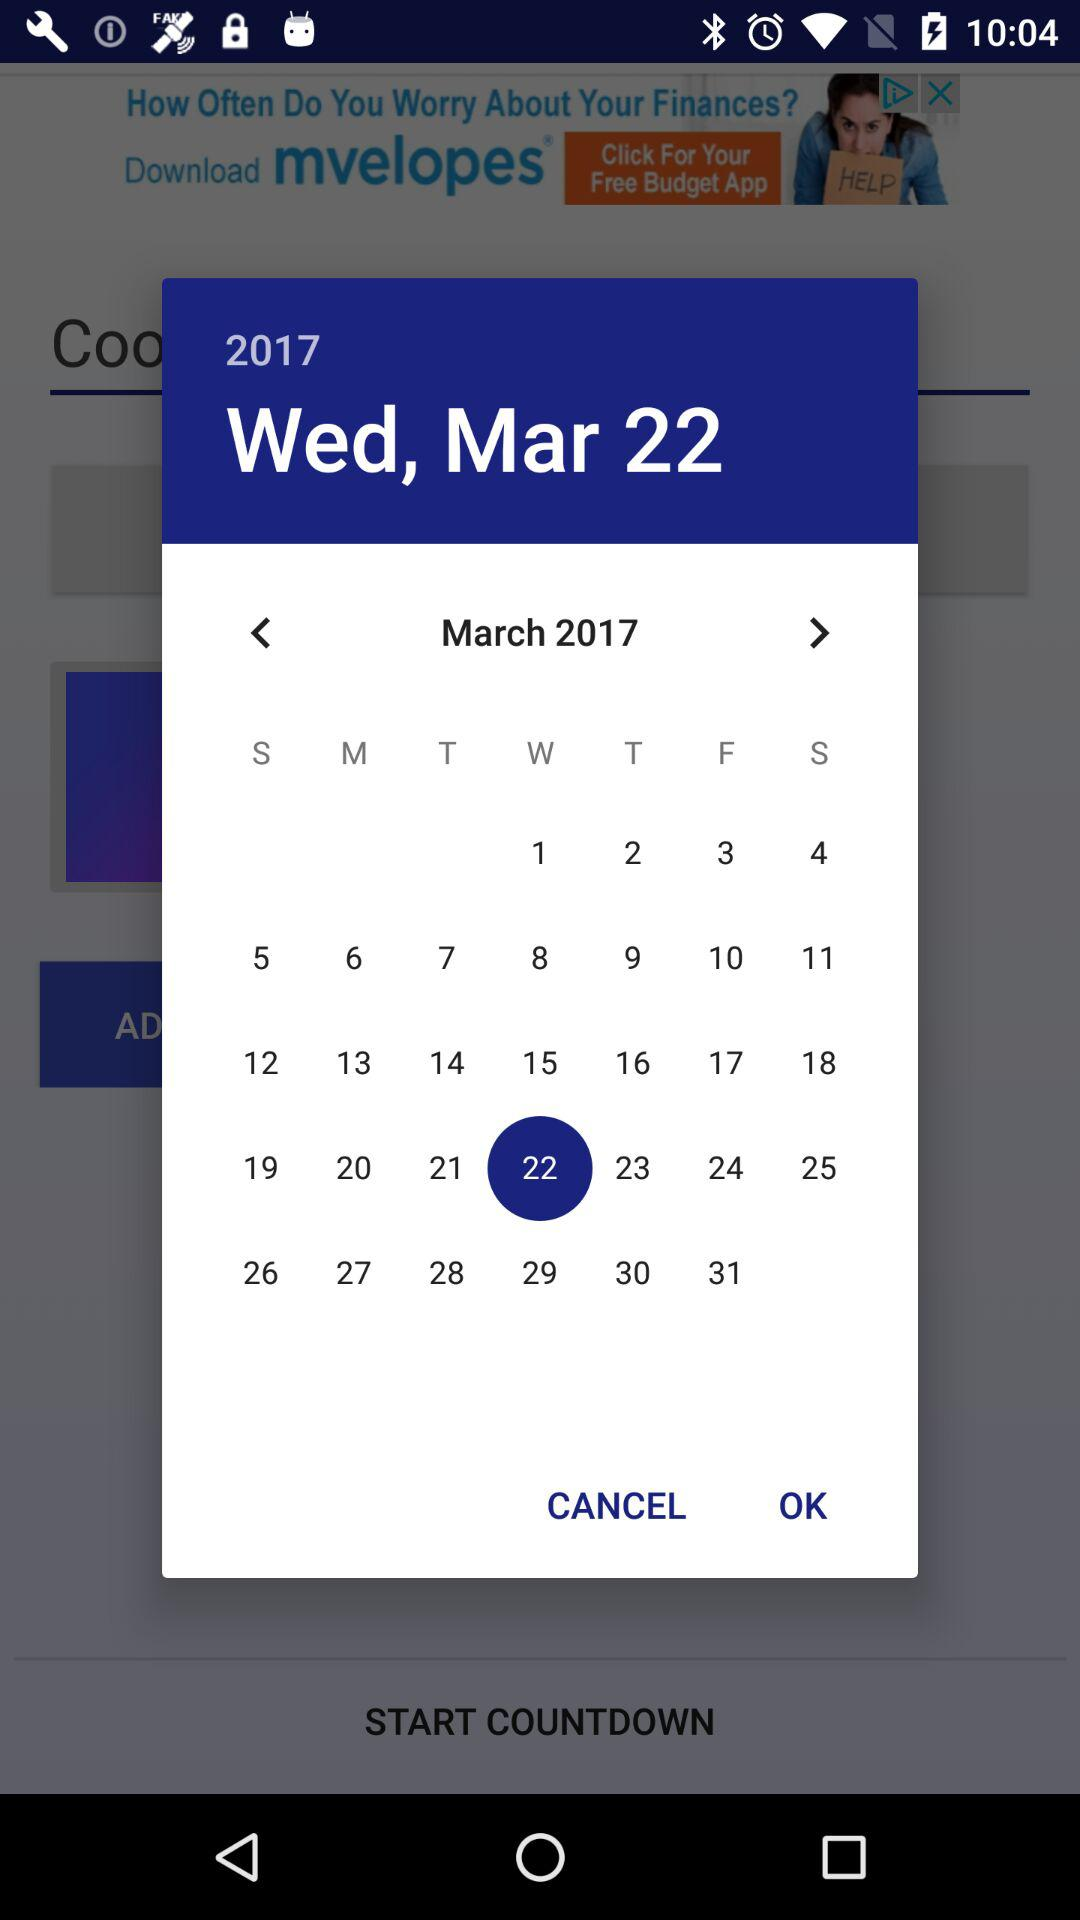Which month and year's calendar is it? The calendar is for March 2017. 